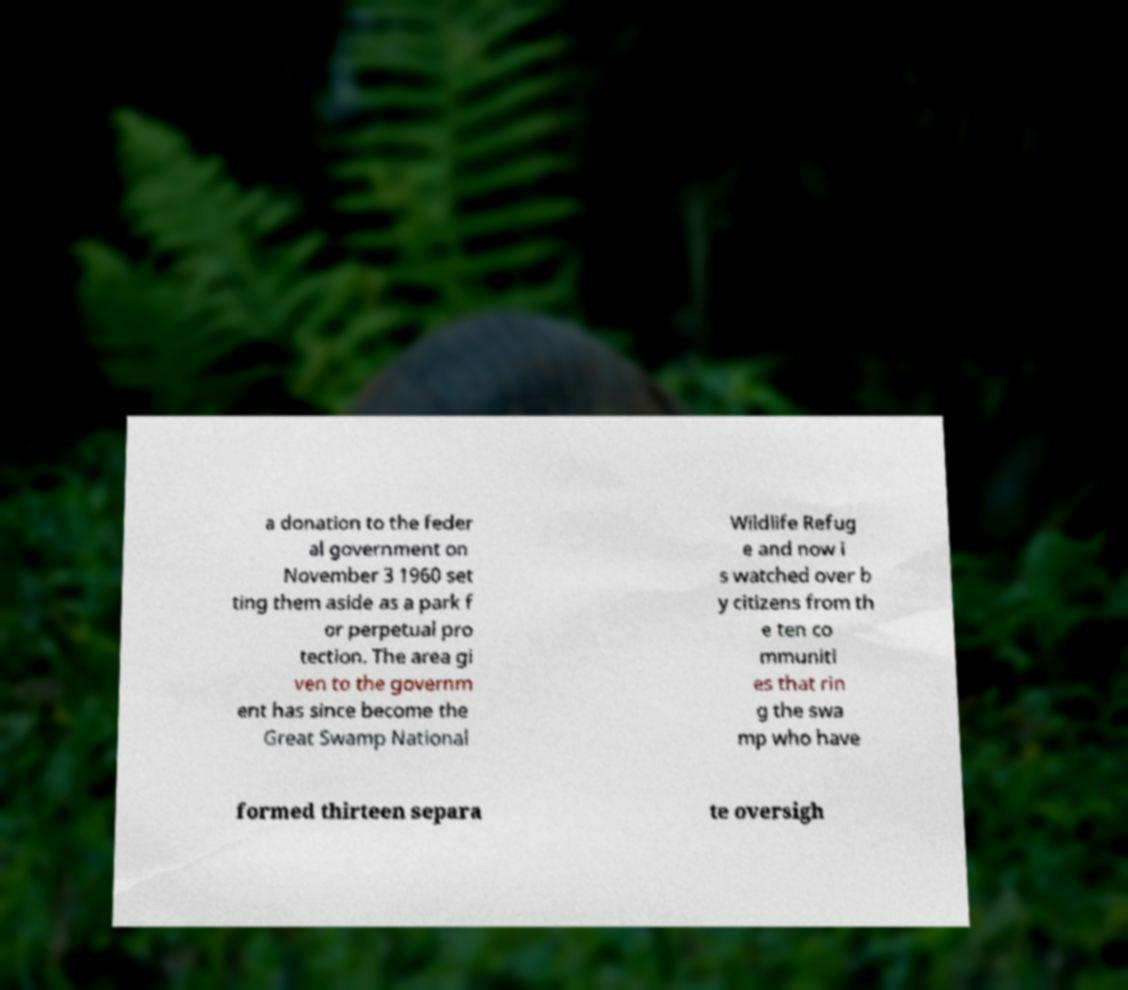Can you accurately transcribe the text from the provided image for me? a donation to the feder al government on November 3 1960 set ting them aside as a park f or perpetual pro tection. The area gi ven to the governm ent has since become the Great Swamp National Wildlife Refug e and now i s watched over b y citizens from th e ten co mmuniti es that rin g the swa mp who have formed thirteen separa te oversigh 